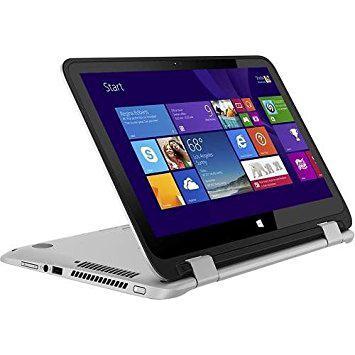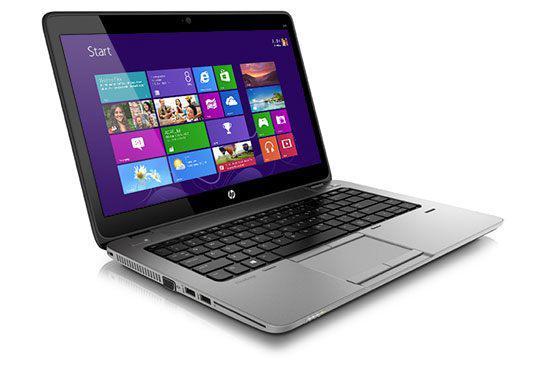The first image is the image on the left, the second image is the image on the right. Evaluate the accuracy of this statement regarding the images: "One of the laptops is standing tent-like, with an image displaying outward on the inverted screen.". Is it true? Answer yes or no. No. The first image is the image on the left, the second image is the image on the right. Evaluate the accuracy of this statement regarding the images: "The image on the left shows a laptop with the keyboard not visible so it can be used as a tablet.". Is it true? Answer yes or no. Yes. 